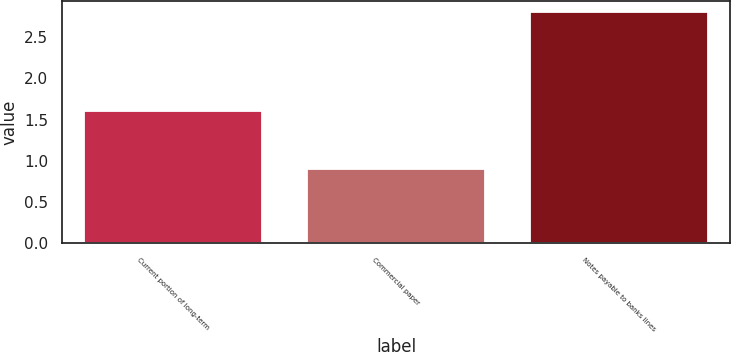Convert chart. <chart><loc_0><loc_0><loc_500><loc_500><bar_chart><fcel>Current portion of long-term<fcel>Commercial paper<fcel>Notes payable to banks lines<nl><fcel>1.6<fcel>0.9<fcel>2.8<nl></chart> 